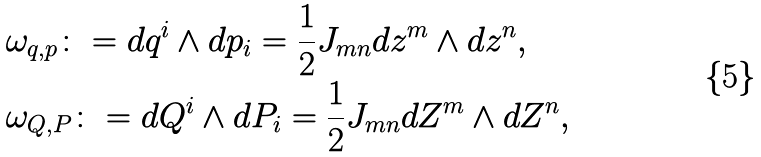<formula> <loc_0><loc_0><loc_500><loc_500>& \omega _ { q , p } \colon = d q ^ { i } \wedge d p _ { i } = \frac { 1 } { 2 } J _ { m n } d z ^ { m } \wedge d z ^ { n } , \\ & \omega _ { Q , P } \colon = d Q ^ { i } \wedge d P _ { i } = \frac { 1 } { 2 } J _ { m n } d Z ^ { m } \wedge d Z ^ { n } ,</formula> 